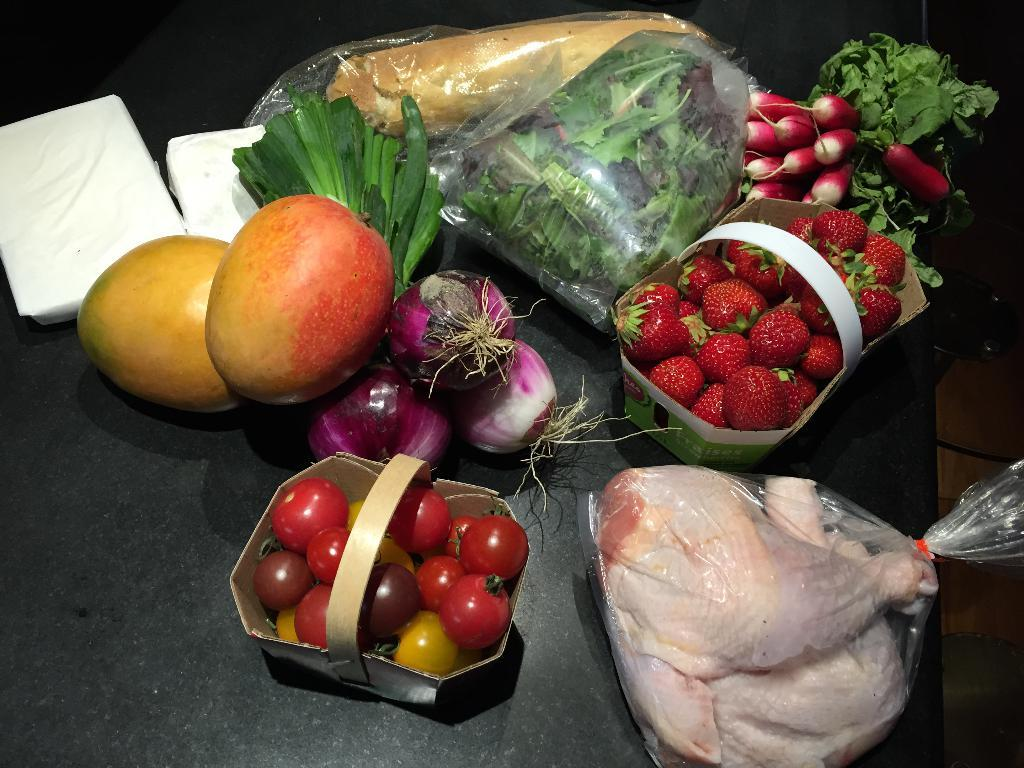What types of food items are present in the image? There are fruits and vegetables in the image. Can you describe the variety of fruits and vegetables in the image? Unfortunately, the specific types of fruits and vegetables are not mentioned in the provided facts. What else can be seen on the table in the image? There are unspecified objects on the table in the image. What type of crate is used to store the pleasure in the image? There is no crate or pleasure present in the image; it features fruits and vegetables on a table. 